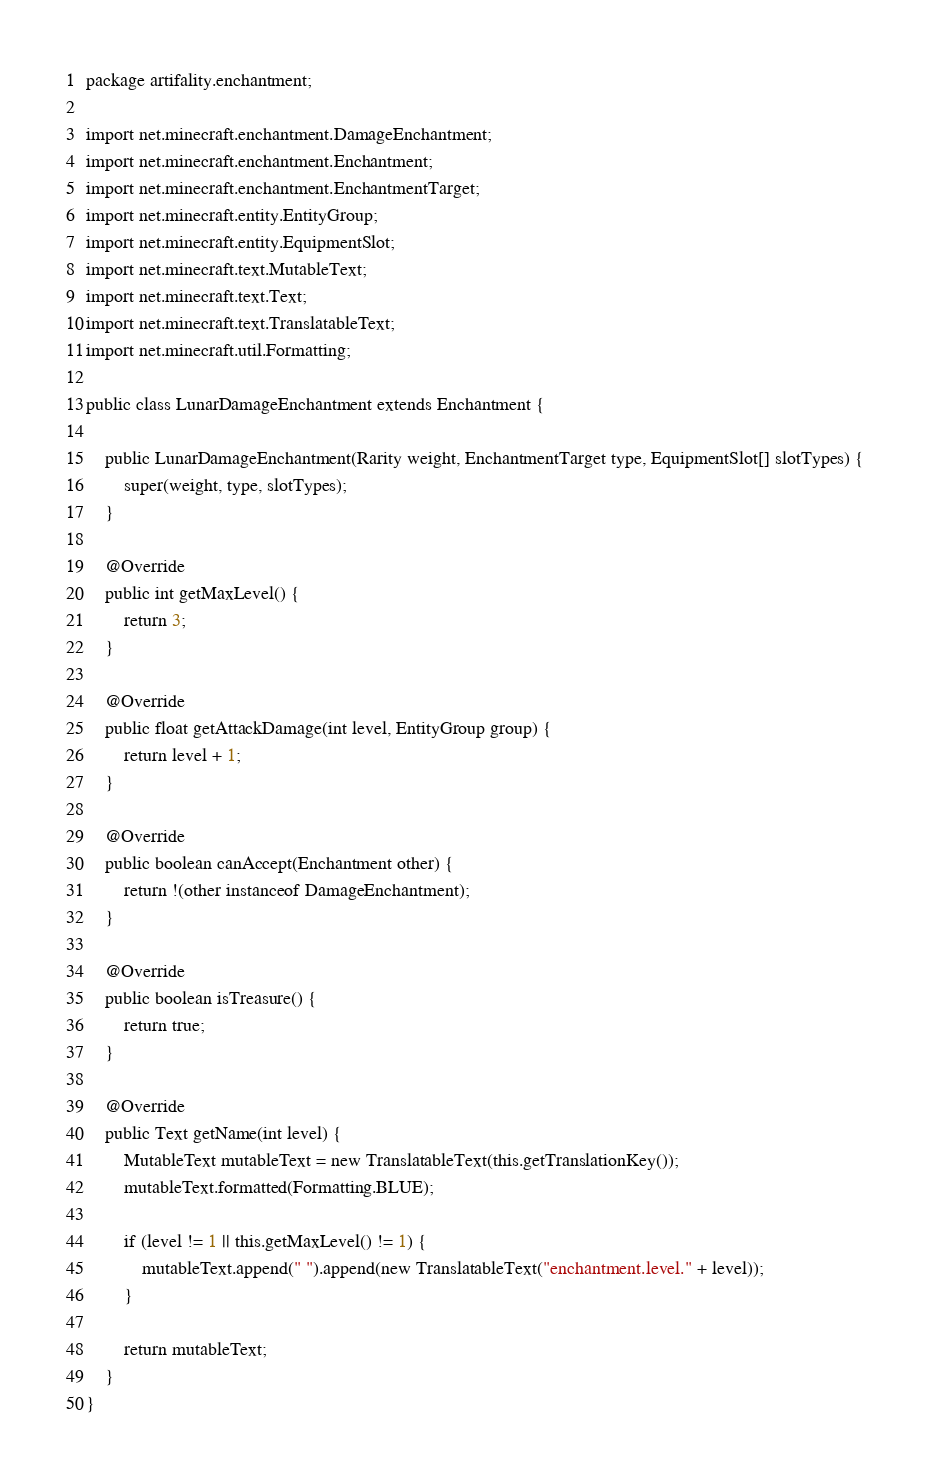Convert code to text. <code><loc_0><loc_0><loc_500><loc_500><_Java_>package artifality.enchantment;

import net.minecraft.enchantment.DamageEnchantment;
import net.minecraft.enchantment.Enchantment;
import net.minecraft.enchantment.EnchantmentTarget;
import net.minecraft.entity.EntityGroup;
import net.minecraft.entity.EquipmentSlot;
import net.minecraft.text.MutableText;
import net.minecraft.text.Text;
import net.minecraft.text.TranslatableText;
import net.minecraft.util.Formatting;

public class LunarDamageEnchantment extends Enchantment {

    public LunarDamageEnchantment(Rarity weight, EnchantmentTarget type, EquipmentSlot[] slotTypes) {
        super(weight, type, slotTypes);
    }

    @Override
    public int getMaxLevel() {
        return 3;
    }

    @Override
    public float getAttackDamage(int level, EntityGroup group) {
        return level + 1;
    }

    @Override
    public boolean canAccept(Enchantment other) {
        return !(other instanceof DamageEnchantment);
    }

    @Override
    public boolean isTreasure() {
        return true;
    }

    @Override
    public Text getName(int level) {
        MutableText mutableText = new TranslatableText(this.getTranslationKey());
        mutableText.formatted(Formatting.BLUE);

        if (level != 1 || this.getMaxLevel() != 1) {
            mutableText.append(" ").append(new TranslatableText("enchantment.level." + level));
        }

        return mutableText;
    }
}
</code> 